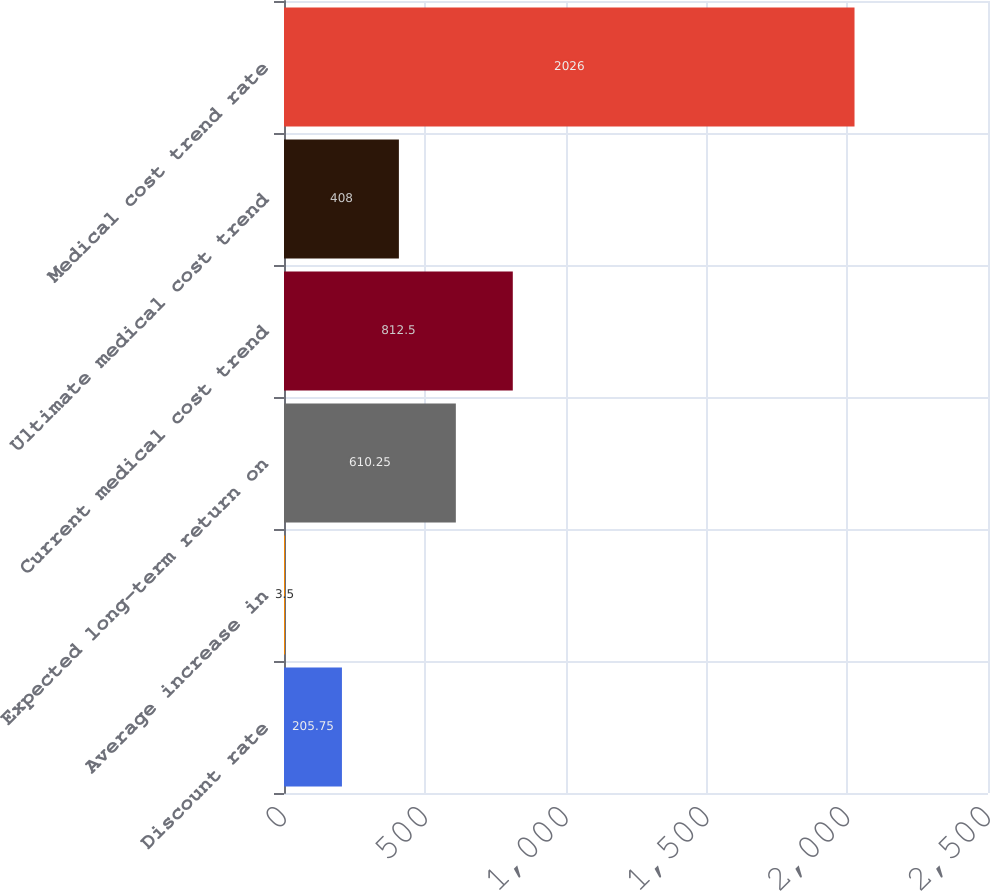<chart> <loc_0><loc_0><loc_500><loc_500><bar_chart><fcel>Discount rate<fcel>Average increase in<fcel>Expected long-term return on<fcel>Current medical cost trend<fcel>Ultimate medical cost trend<fcel>Medical cost trend rate<nl><fcel>205.75<fcel>3.5<fcel>610.25<fcel>812.5<fcel>408<fcel>2026<nl></chart> 